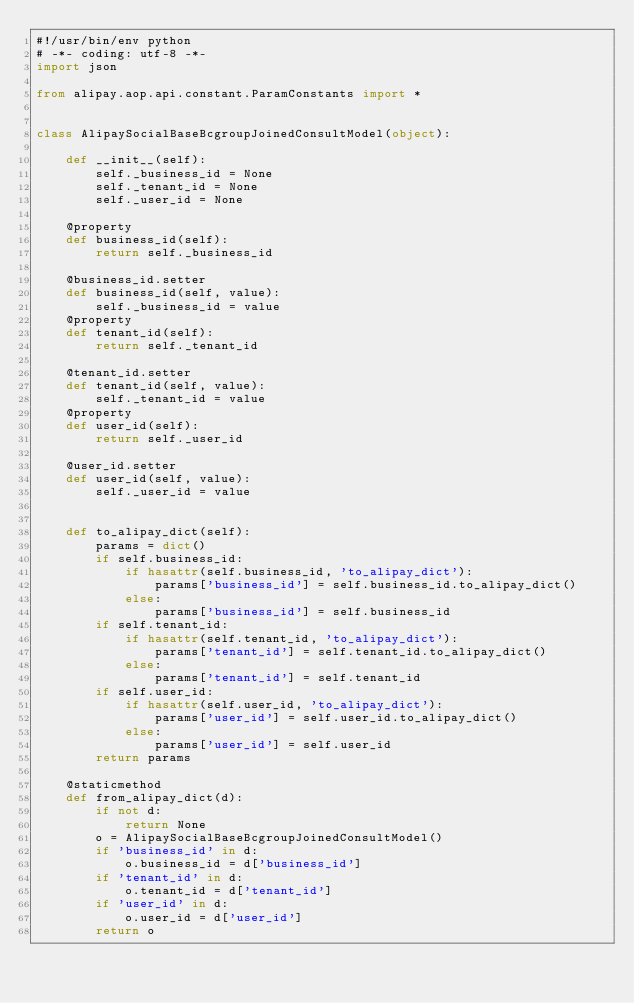<code> <loc_0><loc_0><loc_500><loc_500><_Python_>#!/usr/bin/env python
# -*- coding: utf-8 -*-
import json

from alipay.aop.api.constant.ParamConstants import *


class AlipaySocialBaseBcgroupJoinedConsultModel(object):

    def __init__(self):
        self._business_id = None
        self._tenant_id = None
        self._user_id = None

    @property
    def business_id(self):
        return self._business_id

    @business_id.setter
    def business_id(self, value):
        self._business_id = value
    @property
    def tenant_id(self):
        return self._tenant_id

    @tenant_id.setter
    def tenant_id(self, value):
        self._tenant_id = value
    @property
    def user_id(self):
        return self._user_id

    @user_id.setter
    def user_id(self, value):
        self._user_id = value


    def to_alipay_dict(self):
        params = dict()
        if self.business_id:
            if hasattr(self.business_id, 'to_alipay_dict'):
                params['business_id'] = self.business_id.to_alipay_dict()
            else:
                params['business_id'] = self.business_id
        if self.tenant_id:
            if hasattr(self.tenant_id, 'to_alipay_dict'):
                params['tenant_id'] = self.tenant_id.to_alipay_dict()
            else:
                params['tenant_id'] = self.tenant_id
        if self.user_id:
            if hasattr(self.user_id, 'to_alipay_dict'):
                params['user_id'] = self.user_id.to_alipay_dict()
            else:
                params['user_id'] = self.user_id
        return params

    @staticmethod
    def from_alipay_dict(d):
        if not d:
            return None
        o = AlipaySocialBaseBcgroupJoinedConsultModel()
        if 'business_id' in d:
            o.business_id = d['business_id']
        if 'tenant_id' in d:
            o.tenant_id = d['tenant_id']
        if 'user_id' in d:
            o.user_id = d['user_id']
        return o


</code> 